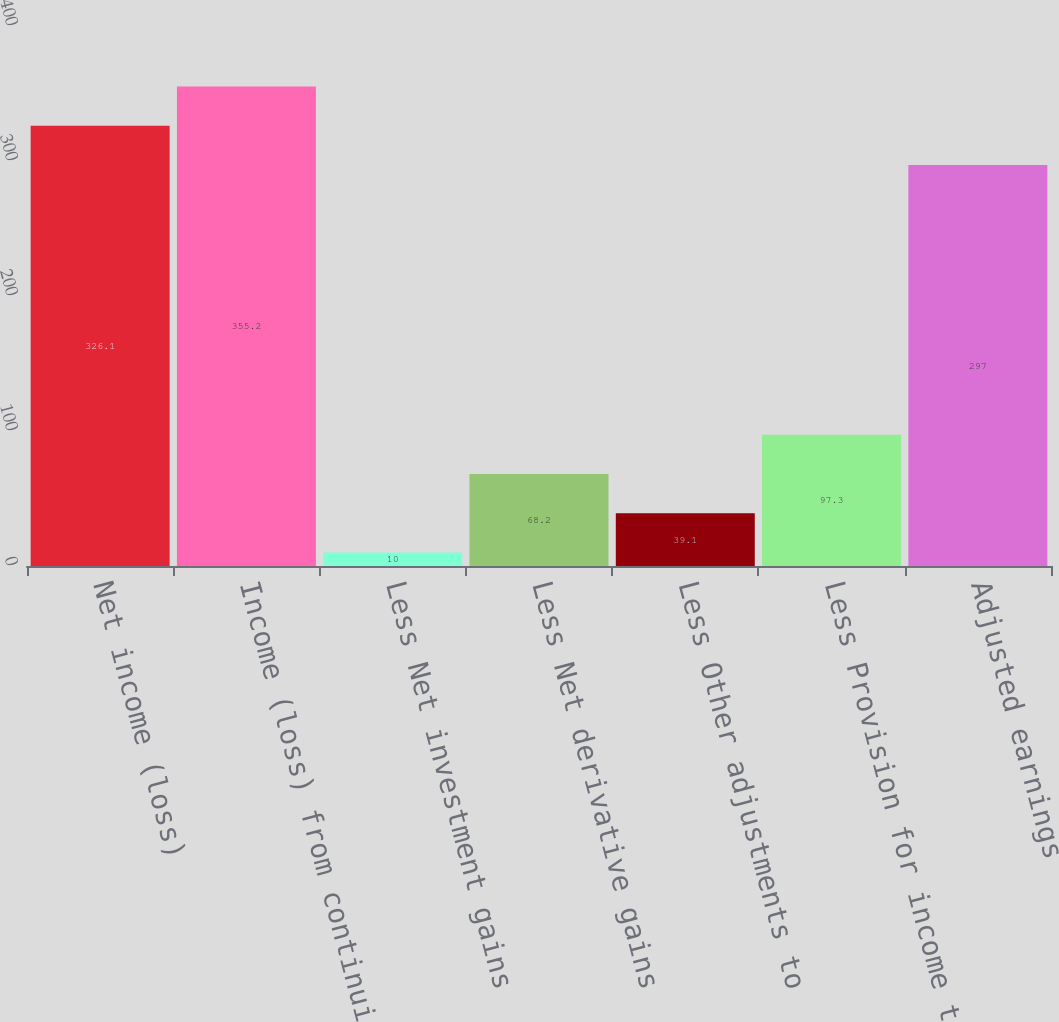Convert chart. <chart><loc_0><loc_0><loc_500><loc_500><bar_chart><fcel>Net income (loss)<fcel>Income (loss) from continuing<fcel>Less Net investment gains<fcel>Less Net derivative gains<fcel>Less Other adjustments to<fcel>Less Provision for income tax<fcel>Adjusted earnings<nl><fcel>326.1<fcel>355.2<fcel>10<fcel>68.2<fcel>39.1<fcel>97.3<fcel>297<nl></chart> 